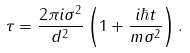Convert formula to latex. <formula><loc_0><loc_0><loc_500><loc_500>\tau = \frac { 2 \pi i \sigma ^ { 2 } } { d ^ { 2 } } \left ( 1 + \frac { i \hbar { t } } { m \sigma ^ { 2 } } \right ) .</formula> 